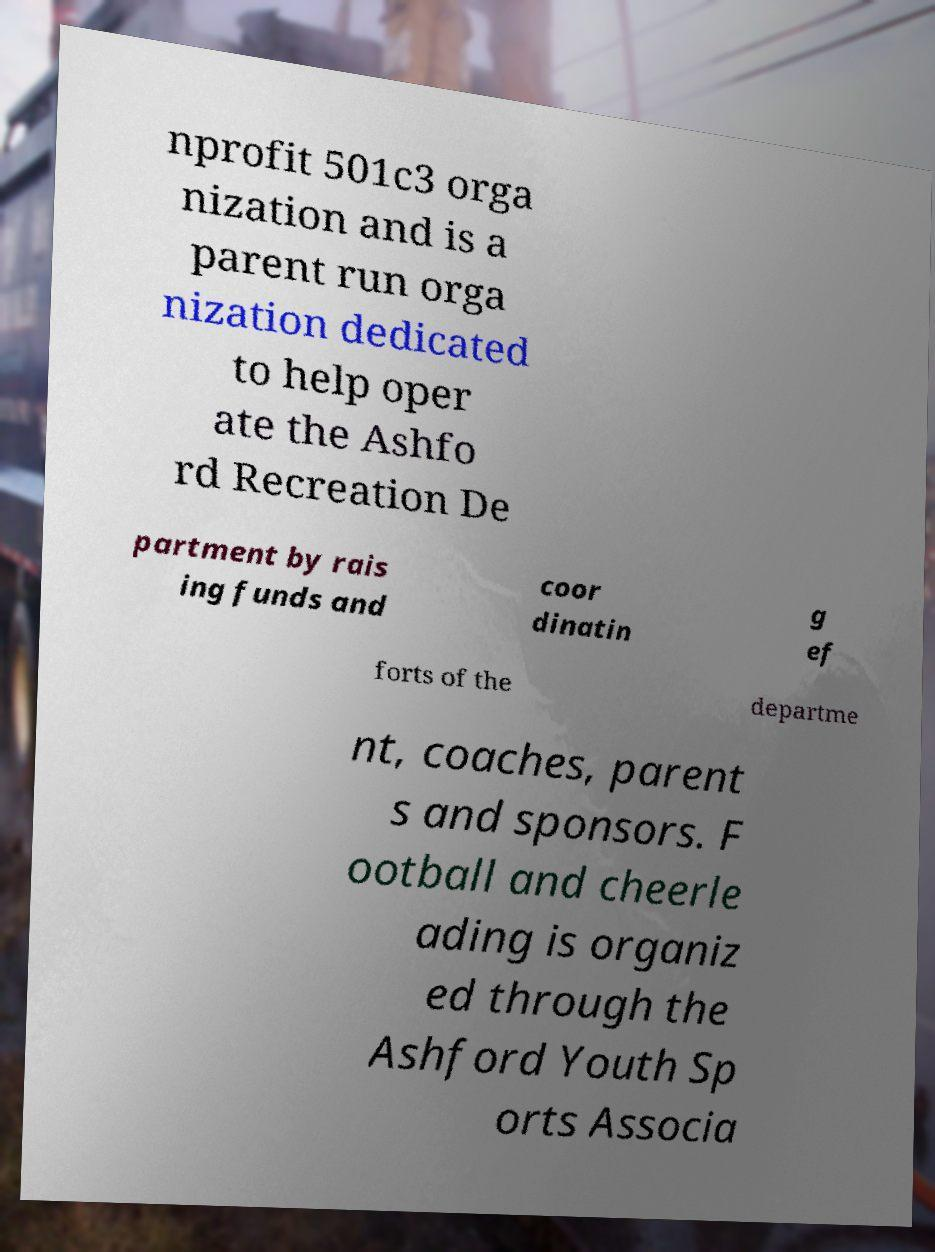There's text embedded in this image that I need extracted. Can you transcribe it verbatim? nprofit 501c3 orga nization and is a parent run orga nization dedicated to help oper ate the Ashfo rd Recreation De partment by rais ing funds and coor dinatin g ef forts of the departme nt, coaches, parent s and sponsors. F ootball and cheerle ading is organiz ed through the Ashford Youth Sp orts Associa 